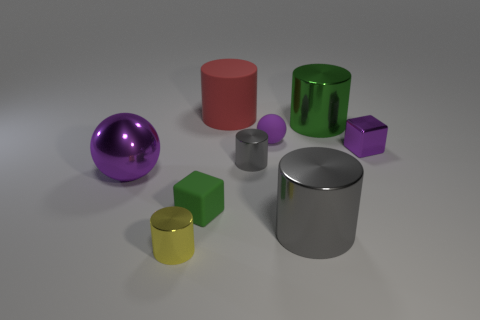Subtract all cyan cylinders. Subtract all purple spheres. How many cylinders are left? 5 Add 1 red spheres. How many objects exist? 10 Subtract all cubes. How many objects are left? 7 Add 6 large purple blocks. How many large purple blocks exist? 6 Subtract 0 cyan cylinders. How many objects are left? 9 Subtract all tiny green spheres. Subtract all big balls. How many objects are left? 8 Add 4 big gray things. How many big gray things are left? 5 